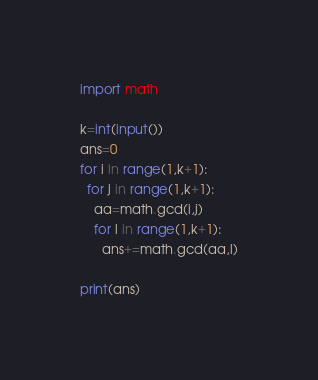Convert code to text. <code><loc_0><loc_0><loc_500><loc_500><_Python_>import math
 
k=int(input())
ans=0
for i in range(1,k+1):
  for j in range(1,k+1):
    aa=math.gcd(i,j)
    for l in range(1,k+1):
      ans+=math.gcd(aa,l)
 
print(ans)</code> 